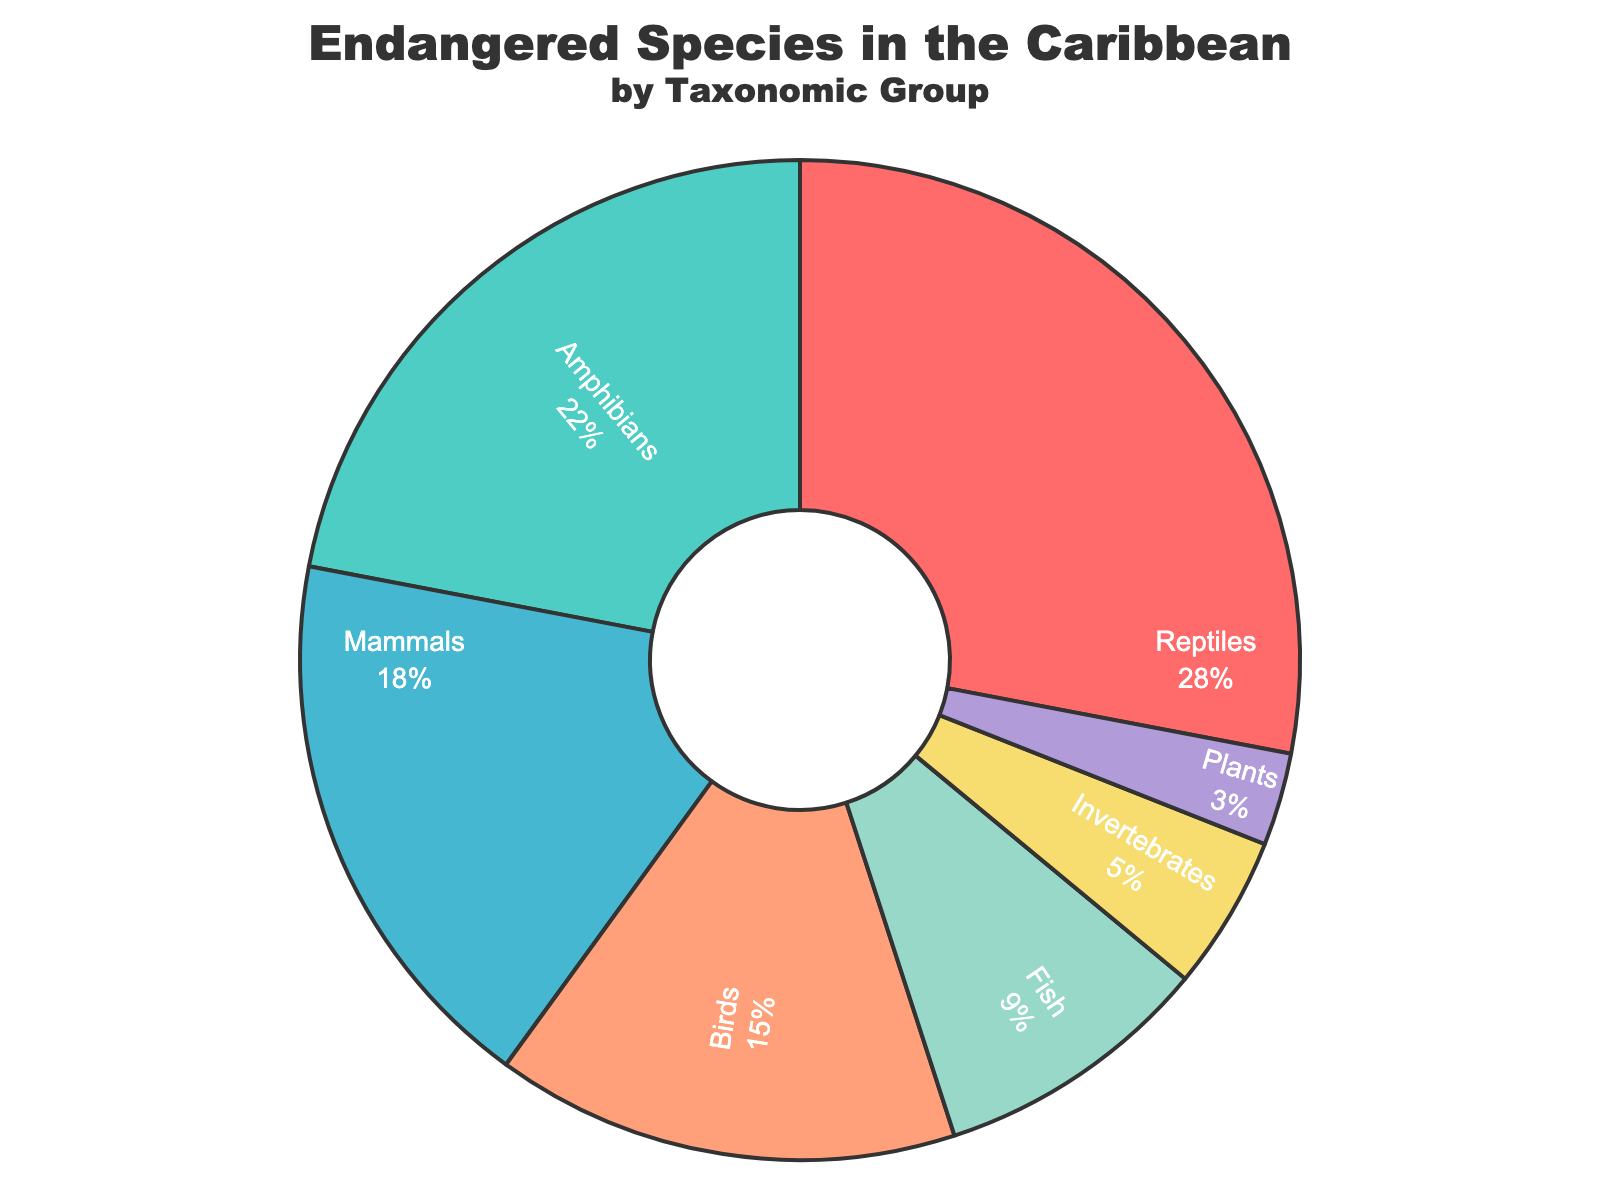What taxonomic group has the highest proportion of endangered species? Reptiles have the largest segment in the pie chart. This indicates they have the highest proportion of endangered species.
Answer: Reptiles What is the combined proportion of endangered mammals and birds? The proportion of endangered mammals is 0.18, and for birds, it is 0.15. Adding these together, 0.18 + 0.15 = 0.33.
Answer: 0.33 Which taxonomic group has the smallest proportion of endangered species? The smallest segment in the pie chart corresponds to plants.
Answer: Plants How much larger is the proportion of endangered reptiles compared to invertebrates? The proportion of endangered reptiles is 0.28, and that of invertebrates is 0.05. The difference is 0.28 - 0.05 = 0.23.
Answer: 0.23 What is the average proportion of endangered species for amphibians, fish, and plants? The proportions are 0.22 for amphibians, 0.09 for fish, and 0.03 for plants. The average is calculated by summing the values and dividing by the number of groups: (0.22 + 0.09 + 0.03) / 3 = 0.34 / 3 ≈ 0.113.
Answer: 0.113 Which taxonomic group has a larger proportion of endangered species, mammals or amphibians? The pie chart shows that amphibians have a proportion of 0.22, and mammals have a proportion of 0.18. Since 0.22 is greater than 0.18, amphibians have a larger proportion.
Answer: Amphibians What percentage of the chart is represented by fish? The proportion of endangered fish is 0.09. To convert this to a percentage, multiply by 100: 0.09 * 100 = 9%.
Answer: 9% What's the total proportion of endangered species if you combine reptiles, amphibians, and mammals? The respective proportions are 0.28, 0.22, and 0.18. Adding these together gives 0.28 + 0.22 + 0.18 = 0.68.
Answer: 0.68 